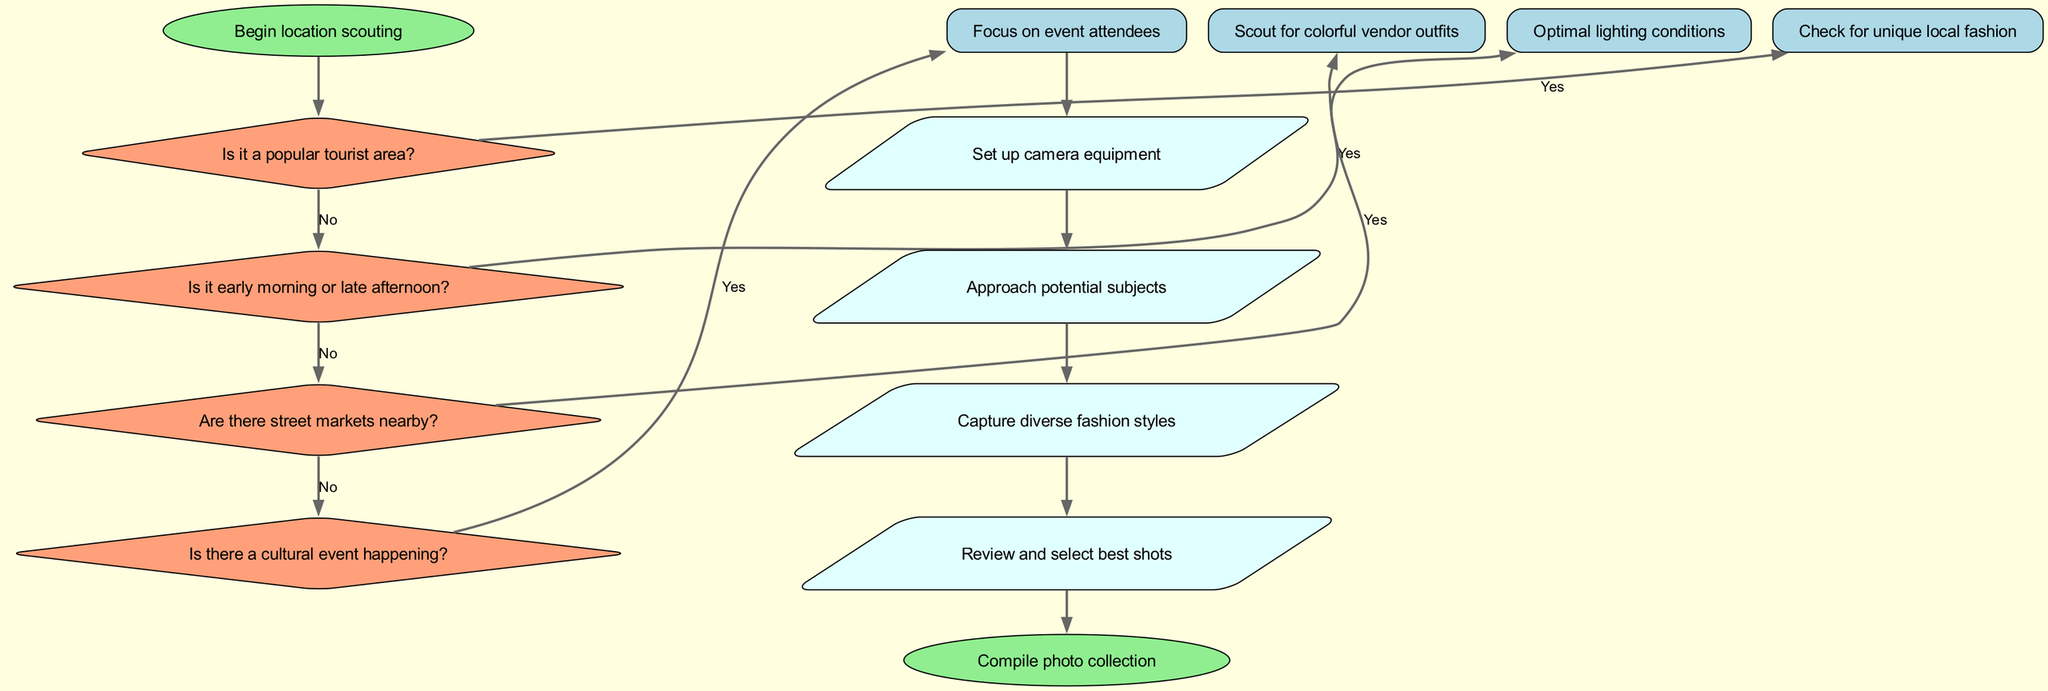What is the starting point of the flowchart? The flowchart begins with the node labeled "Begin location scouting," which marks the initial step in the decision-making process.
Answer: Begin location scouting How many decisions are presented in the diagram? There are four decision nodes in the diagram, each relating to different aspects of selecting locations and times for capturing street fashion in Havana.
Answer: 4 What action follows after confirming unique local fashion in a tourist area? After confirming unique local fashion in a tourist area, the next action is to "Set up camera equipment," which follows from approach decisions.
Answer: Set up camera equipment If a location is not a popular tourist area, what is the next step? If it is not a popular tourist area, the next step is to "Explore residential neighborhoods," which is the response to that specific decision point.
Answer: Explore residential neighborhoods What is the final action in the flowchart? The final action listed in the flowchart is "Compile photo collection," which concludes the documented process after capturing fashion styles.
Answer: Compile photo collection What happens if no cultural event is happening? If there is no cultural event happening, the next observation step is to "Observe daily street life," which allows for capturing regular street fashion.
Answer: Observe daily street life What do you do if it is early morning or late afternoon? If it is early morning or late afternoon, the decision is to proceed with "Optimal lighting conditions," which indicates favorable times for photography.
Answer: Optimal lighting conditions Which decision leads to looking for public squares? The decision that leads to looking for public squares is "Are there street markets nearby?" Answering 'no' to this question redirects the process accordingly.
Answer: Look for public squares 